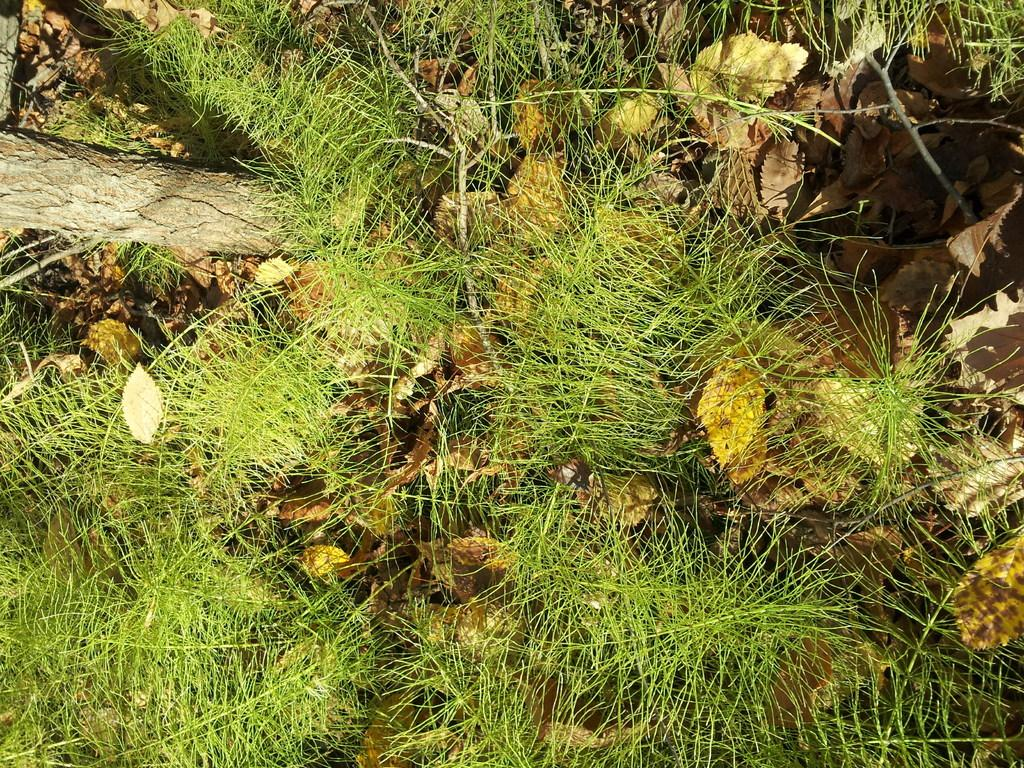What type of plant can be seen in the image? There is a tree in the image. What is covering the ground in the image? There is grass on the ground in the image. What part of the tree is visible in the image? Leaves are visible in the image. What type of animals can be seen at the zoo in the image? There is no zoo present in the image, so it is not possible to determine what animals might be seen there. 